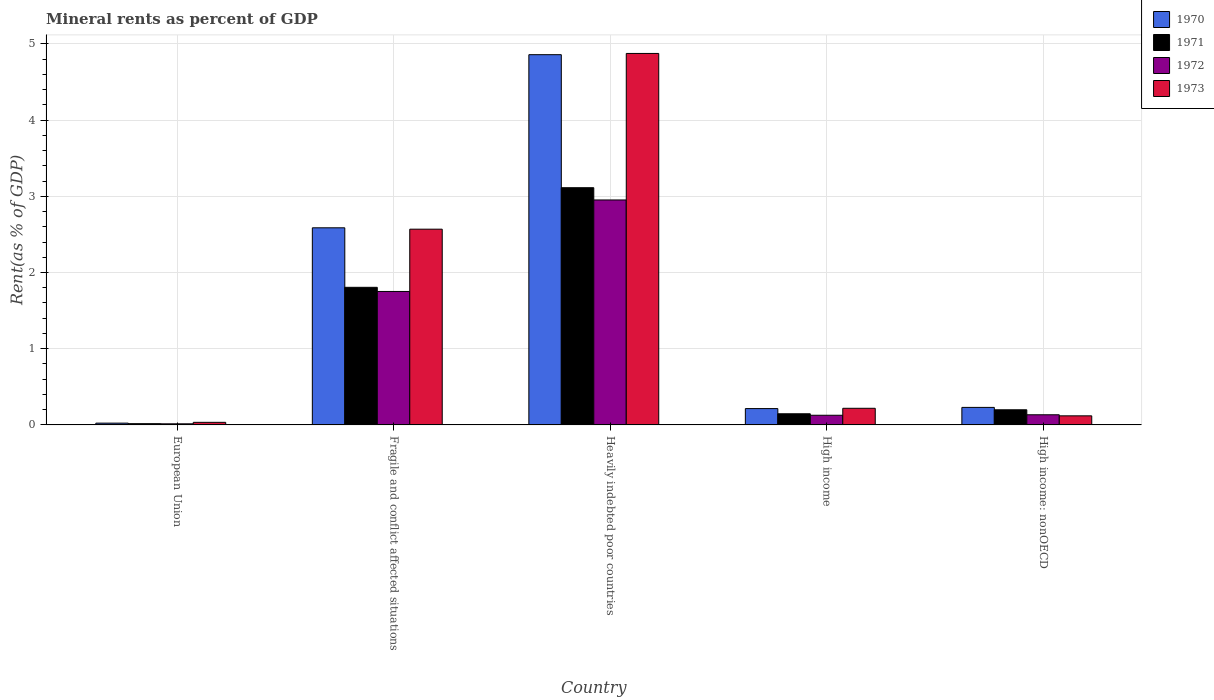How many different coloured bars are there?
Keep it short and to the point. 4. How many groups of bars are there?
Make the answer very short. 5. Are the number of bars on each tick of the X-axis equal?
Offer a very short reply. Yes. How many bars are there on the 2nd tick from the left?
Your response must be concise. 4. How many bars are there on the 1st tick from the right?
Provide a short and direct response. 4. What is the label of the 1st group of bars from the left?
Provide a short and direct response. European Union. What is the mineral rent in 1973 in Fragile and conflict affected situations?
Ensure brevity in your answer.  2.57. Across all countries, what is the maximum mineral rent in 1972?
Ensure brevity in your answer.  2.95. Across all countries, what is the minimum mineral rent in 1973?
Your response must be concise. 0.03. In which country was the mineral rent in 1970 maximum?
Give a very brief answer. Heavily indebted poor countries. In which country was the mineral rent in 1973 minimum?
Your answer should be very brief. European Union. What is the total mineral rent in 1973 in the graph?
Your answer should be compact. 7.81. What is the difference between the mineral rent in 1972 in Fragile and conflict affected situations and that in High income?
Your response must be concise. 1.62. What is the difference between the mineral rent in 1972 in Fragile and conflict affected situations and the mineral rent in 1970 in European Union?
Provide a short and direct response. 1.73. What is the average mineral rent in 1970 per country?
Give a very brief answer. 1.58. What is the difference between the mineral rent of/in 1970 and mineral rent of/in 1971 in Fragile and conflict affected situations?
Offer a terse response. 0.78. What is the ratio of the mineral rent in 1973 in Fragile and conflict affected situations to that in Heavily indebted poor countries?
Your response must be concise. 0.53. What is the difference between the highest and the second highest mineral rent in 1972?
Provide a succinct answer. -1.62. What is the difference between the highest and the lowest mineral rent in 1970?
Keep it short and to the point. 4.83. In how many countries, is the mineral rent in 1973 greater than the average mineral rent in 1973 taken over all countries?
Your answer should be very brief. 2. Is the sum of the mineral rent in 1970 in Fragile and conflict affected situations and High income: nonOECD greater than the maximum mineral rent in 1971 across all countries?
Your answer should be compact. No. What does the 1st bar from the left in European Union represents?
Make the answer very short. 1970. How many bars are there?
Your response must be concise. 20. Are all the bars in the graph horizontal?
Offer a terse response. No. What is the difference between two consecutive major ticks on the Y-axis?
Ensure brevity in your answer.  1. Are the values on the major ticks of Y-axis written in scientific E-notation?
Provide a short and direct response. No. Does the graph contain grids?
Provide a succinct answer. Yes. Where does the legend appear in the graph?
Offer a very short reply. Top right. How many legend labels are there?
Your response must be concise. 4. How are the legend labels stacked?
Keep it short and to the point. Vertical. What is the title of the graph?
Offer a very short reply. Mineral rents as percent of GDP. What is the label or title of the Y-axis?
Provide a succinct answer. Rent(as % of GDP). What is the Rent(as % of GDP) of 1970 in European Union?
Your response must be concise. 0.02. What is the Rent(as % of GDP) of 1971 in European Union?
Your response must be concise. 0.02. What is the Rent(as % of GDP) of 1972 in European Union?
Offer a terse response. 0.01. What is the Rent(as % of GDP) of 1973 in European Union?
Make the answer very short. 0.03. What is the Rent(as % of GDP) of 1970 in Fragile and conflict affected situations?
Offer a very short reply. 2.59. What is the Rent(as % of GDP) in 1971 in Fragile and conflict affected situations?
Your answer should be very brief. 1.81. What is the Rent(as % of GDP) in 1972 in Fragile and conflict affected situations?
Keep it short and to the point. 1.75. What is the Rent(as % of GDP) of 1973 in Fragile and conflict affected situations?
Give a very brief answer. 2.57. What is the Rent(as % of GDP) in 1970 in Heavily indebted poor countries?
Provide a short and direct response. 4.86. What is the Rent(as % of GDP) in 1971 in Heavily indebted poor countries?
Your answer should be very brief. 3.11. What is the Rent(as % of GDP) of 1972 in Heavily indebted poor countries?
Ensure brevity in your answer.  2.95. What is the Rent(as % of GDP) of 1973 in Heavily indebted poor countries?
Keep it short and to the point. 4.87. What is the Rent(as % of GDP) in 1970 in High income?
Your answer should be compact. 0.21. What is the Rent(as % of GDP) in 1971 in High income?
Give a very brief answer. 0.15. What is the Rent(as % of GDP) of 1972 in High income?
Your response must be concise. 0.13. What is the Rent(as % of GDP) of 1973 in High income?
Ensure brevity in your answer.  0.22. What is the Rent(as % of GDP) in 1970 in High income: nonOECD?
Your answer should be compact. 0.23. What is the Rent(as % of GDP) of 1971 in High income: nonOECD?
Ensure brevity in your answer.  0.2. What is the Rent(as % of GDP) in 1972 in High income: nonOECD?
Your answer should be compact. 0.13. What is the Rent(as % of GDP) in 1973 in High income: nonOECD?
Provide a short and direct response. 0.12. Across all countries, what is the maximum Rent(as % of GDP) of 1970?
Provide a short and direct response. 4.86. Across all countries, what is the maximum Rent(as % of GDP) in 1971?
Offer a terse response. 3.11. Across all countries, what is the maximum Rent(as % of GDP) in 1972?
Offer a very short reply. 2.95. Across all countries, what is the maximum Rent(as % of GDP) in 1973?
Make the answer very short. 4.87. Across all countries, what is the minimum Rent(as % of GDP) of 1970?
Make the answer very short. 0.02. Across all countries, what is the minimum Rent(as % of GDP) of 1971?
Your answer should be compact. 0.02. Across all countries, what is the minimum Rent(as % of GDP) of 1972?
Give a very brief answer. 0.01. Across all countries, what is the minimum Rent(as % of GDP) in 1973?
Provide a succinct answer. 0.03. What is the total Rent(as % of GDP) of 1970 in the graph?
Provide a short and direct response. 7.91. What is the total Rent(as % of GDP) in 1971 in the graph?
Offer a very short reply. 5.28. What is the total Rent(as % of GDP) of 1972 in the graph?
Give a very brief answer. 4.98. What is the total Rent(as % of GDP) of 1973 in the graph?
Your response must be concise. 7.81. What is the difference between the Rent(as % of GDP) in 1970 in European Union and that in Fragile and conflict affected situations?
Provide a short and direct response. -2.56. What is the difference between the Rent(as % of GDP) in 1971 in European Union and that in Fragile and conflict affected situations?
Offer a terse response. -1.79. What is the difference between the Rent(as % of GDP) of 1972 in European Union and that in Fragile and conflict affected situations?
Provide a short and direct response. -1.74. What is the difference between the Rent(as % of GDP) in 1973 in European Union and that in Fragile and conflict affected situations?
Make the answer very short. -2.53. What is the difference between the Rent(as % of GDP) of 1970 in European Union and that in Heavily indebted poor countries?
Offer a very short reply. -4.83. What is the difference between the Rent(as % of GDP) in 1971 in European Union and that in Heavily indebted poor countries?
Ensure brevity in your answer.  -3.1. What is the difference between the Rent(as % of GDP) in 1972 in European Union and that in Heavily indebted poor countries?
Your answer should be compact. -2.94. What is the difference between the Rent(as % of GDP) of 1973 in European Union and that in Heavily indebted poor countries?
Keep it short and to the point. -4.84. What is the difference between the Rent(as % of GDP) in 1970 in European Union and that in High income?
Your answer should be very brief. -0.19. What is the difference between the Rent(as % of GDP) of 1971 in European Union and that in High income?
Your answer should be very brief. -0.13. What is the difference between the Rent(as % of GDP) in 1972 in European Union and that in High income?
Provide a short and direct response. -0.11. What is the difference between the Rent(as % of GDP) in 1973 in European Union and that in High income?
Offer a very short reply. -0.18. What is the difference between the Rent(as % of GDP) in 1970 in European Union and that in High income: nonOECD?
Your response must be concise. -0.21. What is the difference between the Rent(as % of GDP) of 1971 in European Union and that in High income: nonOECD?
Ensure brevity in your answer.  -0.18. What is the difference between the Rent(as % of GDP) of 1972 in European Union and that in High income: nonOECD?
Your answer should be very brief. -0.12. What is the difference between the Rent(as % of GDP) of 1973 in European Union and that in High income: nonOECD?
Your response must be concise. -0.09. What is the difference between the Rent(as % of GDP) of 1970 in Fragile and conflict affected situations and that in Heavily indebted poor countries?
Make the answer very short. -2.27. What is the difference between the Rent(as % of GDP) in 1971 in Fragile and conflict affected situations and that in Heavily indebted poor countries?
Offer a terse response. -1.31. What is the difference between the Rent(as % of GDP) of 1972 in Fragile and conflict affected situations and that in Heavily indebted poor countries?
Offer a very short reply. -1.2. What is the difference between the Rent(as % of GDP) of 1973 in Fragile and conflict affected situations and that in Heavily indebted poor countries?
Ensure brevity in your answer.  -2.31. What is the difference between the Rent(as % of GDP) in 1970 in Fragile and conflict affected situations and that in High income?
Ensure brevity in your answer.  2.37. What is the difference between the Rent(as % of GDP) of 1971 in Fragile and conflict affected situations and that in High income?
Make the answer very short. 1.66. What is the difference between the Rent(as % of GDP) in 1972 in Fragile and conflict affected situations and that in High income?
Make the answer very short. 1.62. What is the difference between the Rent(as % of GDP) in 1973 in Fragile and conflict affected situations and that in High income?
Provide a succinct answer. 2.35. What is the difference between the Rent(as % of GDP) of 1970 in Fragile and conflict affected situations and that in High income: nonOECD?
Ensure brevity in your answer.  2.36. What is the difference between the Rent(as % of GDP) in 1971 in Fragile and conflict affected situations and that in High income: nonOECD?
Your answer should be compact. 1.61. What is the difference between the Rent(as % of GDP) in 1972 in Fragile and conflict affected situations and that in High income: nonOECD?
Make the answer very short. 1.62. What is the difference between the Rent(as % of GDP) of 1973 in Fragile and conflict affected situations and that in High income: nonOECD?
Keep it short and to the point. 2.45. What is the difference between the Rent(as % of GDP) in 1970 in Heavily indebted poor countries and that in High income?
Provide a succinct answer. 4.64. What is the difference between the Rent(as % of GDP) in 1971 in Heavily indebted poor countries and that in High income?
Keep it short and to the point. 2.97. What is the difference between the Rent(as % of GDP) of 1972 in Heavily indebted poor countries and that in High income?
Keep it short and to the point. 2.82. What is the difference between the Rent(as % of GDP) in 1973 in Heavily indebted poor countries and that in High income?
Provide a succinct answer. 4.66. What is the difference between the Rent(as % of GDP) of 1970 in Heavily indebted poor countries and that in High income: nonOECD?
Offer a very short reply. 4.63. What is the difference between the Rent(as % of GDP) in 1971 in Heavily indebted poor countries and that in High income: nonOECD?
Offer a terse response. 2.91. What is the difference between the Rent(as % of GDP) of 1972 in Heavily indebted poor countries and that in High income: nonOECD?
Provide a succinct answer. 2.82. What is the difference between the Rent(as % of GDP) of 1973 in Heavily indebted poor countries and that in High income: nonOECD?
Provide a short and direct response. 4.75. What is the difference between the Rent(as % of GDP) of 1970 in High income and that in High income: nonOECD?
Offer a terse response. -0.02. What is the difference between the Rent(as % of GDP) of 1971 in High income and that in High income: nonOECD?
Give a very brief answer. -0.05. What is the difference between the Rent(as % of GDP) in 1972 in High income and that in High income: nonOECD?
Your answer should be compact. -0.01. What is the difference between the Rent(as % of GDP) of 1973 in High income and that in High income: nonOECD?
Your answer should be very brief. 0.1. What is the difference between the Rent(as % of GDP) in 1970 in European Union and the Rent(as % of GDP) in 1971 in Fragile and conflict affected situations?
Your response must be concise. -1.78. What is the difference between the Rent(as % of GDP) in 1970 in European Union and the Rent(as % of GDP) in 1972 in Fragile and conflict affected situations?
Ensure brevity in your answer.  -1.73. What is the difference between the Rent(as % of GDP) in 1970 in European Union and the Rent(as % of GDP) in 1973 in Fragile and conflict affected situations?
Make the answer very short. -2.54. What is the difference between the Rent(as % of GDP) of 1971 in European Union and the Rent(as % of GDP) of 1972 in Fragile and conflict affected situations?
Give a very brief answer. -1.73. What is the difference between the Rent(as % of GDP) of 1971 in European Union and the Rent(as % of GDP) of 1973 in Fragile and conflict affected situations?
Offer a terse response. -2.55. What is the difference between the Rent(as % of GDP) of 1972 in European Union and the Rent(as % of GDP) of 1973 in Fragile and conflict affected situations?
Ensure brevity in your answer.  -2.55. What is the difference between the Rent(as % of GDP) of 1970 in European Union and the Rent(as % of GDP) of 1971 in Heavily indebted poor countries?
Ensure brevity in your answer.  -3.09. What is the difference between the Rent(as % of GDP) in 1970 in European Union and the Rent(as % of GDP) in 1972 in Heavily indebted poor countries?
Offer a very short reply. -2.93. What is the difference between the Rent(as % of GDP) of 1970 in European Union and the Rent(as % of GDP) of 1973 in Heavily indebted poor countries?
Keep it short and to the point. -4.85. What is the difference between the Rent(as % of GDP) of 1971 in European Union and the Rent(as % of GDP) of 1972 in Heavily indebted poor countries?
Make the answer very short. -2.94. What is the difference between the Rent(as % of GDP) of 1971 in European Union and the Rent(as % of GDP) of 1973 in Heavily indebted poor countries?
Keep it short and to the point. -4.86. What is the difference between the Rent(as % of GDP) in 1972 in European Union and the Rent(as % of GDP) in 1973 in Heavily indebted poor countries?
Offer a terse response. -4.86. What is the difference between the Rent(as % of GDP) of 1970 in European Union and the Rent(as % of GDP) of 1971 in High income?
Give a very brief answer. -0.12. What is the difference between the Rent(as % of GDP) in 1970 in European Union and the Rent(as % of GDP) in 1972 in High income?
Provide a short and direct response. -0.1. What is the difference between the Rent(as % of GDP) of 1970 in European Union and the Rent(as % of GDP) of 1973 in High income?
Your answer should be very brief. -0.19. What is the difference between the Rent(as % of GDP) in 1971 in European Union and the Rent(as % of GDP) in 1972 in High income?
Keep it short and to the point. -0.11. What is the difference between the Rent(as % of GDP) of 1971 in European Union and the Rent(as % of GDP) of 1973 in High income?
Ensure brevity in your answer.  -0.2. What is the difference between the Rent(as % of GDP) in 1972 in European Union and the Rent(as % of GDP) in 1973 in High income?
Offer a terse response. -0.2. What is the difference between the Rent(as % of GDP) of 1970 in European Union and the Rent(as % of GDP) of 1971 in High income: nonOECD?
Offer a terse response. -0.18. What is the difference between the Rent(as % of GDP) in 1970 in European Union and the Rent(as % of GDP) in 1972 in High income: nonOECD?
Provide a short and direct response. -0.11. What is the difference between the Rent(as % of GDP) of 1970 in European Union and the Rent(as % of GDP) of 1973 in High income: nonOECD?
Provide a succinct answer. -0.1. What is the difference between the Rent(as % of GDP) in 1971 in European Union and the Rent(as % of GDP) in 1972 in High income: nonOECD?
Keep it short and to the point. -0.12. What is the difference between the Rent(as % of GDP) of 1971 in European Union and the Rent(as % of GDP) of 1973 in High income: nonOECD?
Offer a terse response. -0.1. What is the difference between the Rent(as % of GDP) in 1972 in European Union and the Rent(as % of GDP) in 1973 in High income: nonOECD?
Offer a very short reply. -0.1. What is the difference between the Rent(as % of GDP) of 1970 in Fragile and conflict affected situations and the Rent(as % of GDP) of 1971 in Heavily indebted poor countries?
Your answer should be compact. -0.53. What is the difference between the Rent(as % of GDP) of 1970 in Fragile and conflict affected situations and the Rent(as % of GDP) of 1972 in Heavily indebted poor countries?
Provide a short and direct response. -0.37. What is the difference between the Rent(as % of GDP) in 1970 in Fragile and conflict affected situations and the Rent(as % of GDP) in 1973 in Heavily indebted poor countries?
Give a very brief answer. -2.29. What is the difference between the Rent(as % of GDP) in 1971 in Fragile and conflict affected situations and the Rent(as % of GDP) in 1972 in Heavily indebted poor countries?
Offer a very short reply. -1.15. What is the difference between the Rent(as % of GDP) of 1971 in Fragile and conflict affected situations and the Rent(as % of GDP) of 1973 in Heavily indebted poor countries?
Offer a very short reply. -3.07. What is the difference between the Rent(as % of GDP) of 1972 in Fragile and conflict affected situations and the Rent(as % of GDP) of 1973 in Heavily indebted poor countries?
Your answer should be very brief. -3.12. What is the difference between the Rent(as % of GDP) in 1970 in Fragile and conflict affected situations and the Rent(as % of GDP) in 1971 in High income?
Provide a succinct answer. 2.44. What is the difference between the Rent(as % of GDP) in 1970 in Fragile and conflict affected situations and the Rent(as % of GDP) in 1972 in High income?
Keep it short and to the point. 2.46. What is the difference between the Rent(as % of GDP) in 1970 in Fragile and conflict affected situations and the Rent(as % of GDP) in 1973 in High income?
Give a very brief answer. 2.37. What is the difference between the Rent(as % of GDP) of 1971 in Fragile and conflict affected situations and the Rent(as % of GDP) of 1972 in High income?
Provide a short and direct response. 1.68. What is the difference between the Rent(as % of GDP) in 1971 in Fragile and conflict affected situations and the Rent(as % of GDP) in 1973 in High income?
Keep it short and to the point. 1.59. What is the difference between the Rent(as % of GDP) of 1972 in Fragile and conflict affected situations and the Rent(as % of GDP) of 1973 in High income?
Offer a terse response. 1.53. What is the difference between the Rent(as % of GDP) in 1970 in Fragile and conflict affected situations and the Rent(as % of GDP) in 1971 in High income: nonOECD?
Provide a short and direct response. 2.39. What is the difference between the Rent(as % of GDP) of 1970 in Fragile and conflict affected situations and the Rent(as % of GDP) of 1972 in High income: nonOECD?
Offer a very short reply. 2.45. What is the difference between the Rent(as % of GDP) of 1970 in Fragile and conflict affected situations and the Rent(as % of GDP) of 1973 in High income: nonOECD?
Your answer should be compact. 2.47. What is the difference between the Rent(as % of GDP) of 1971 in Fragile and conflict affected situations and the Rent(as % of GDP) of 1972 in High income: nonOECD?
Your answer should be compact. 1.67. What is the difference between the Rent(as % of GDP) of 1971 in Fragile and conflict affected situations and the Rent(as % of GDP) of 1973 in High income: nonOECD?
Keep it short and to the point. 1.69. What is the difference between the Rent(as % of GDP) in 1972 in Fragile and conflict affected situations and the Rent(as % of GDP) in 1973 in High income: nonOECD?
Offer a terse response. 1.63. What is the difference between the Rent(as % of GDP) of 1970 in Heavily indebted poor countries and the Rent(as % of GDP) of 1971 in High income?
Provide a succinct answer. 4.71. What is the difference between the Rent(as % of GDP) of 1970 in Heavily indebted poor countries and the Rent(as % of GDP) of 1972 in High income?
Your answer should be compact. 4.73. What is the difference between the Rent(as % of GDP) in 1970 in Heavily indebted poor countries and the Rent(as % of GDP) in 1973 in High income?
Your answer should be very brief. 4.64. What is the difference between the Rent(as % of GDP) of 1971 in Heavily indebted poor countries and the Rent(as % of GDP) of 1972 in High income?
Keep it short and to the point. 2.99. What is the difference between the Rent(as % of GDP) of 1971 in Heavily indebted poor countries and the Rent(as % of GDP) of 1973 in High income?
Ensure brevity in your answer.  2.89. What is the difference between the Rent(as % of GDP) in 1972 in Heavily indebted poor countries and the Rent(as % of GDP) in 1973 in High income?
Make the answer very short. 2.73. What is the difference between the Rent(as % of GDP) of 1970 in Heavily indebted poor countries and the Rent(as % of GDP) of 1971 in High income: nonOECD?
Your answer should be very brief. 4.66. What is the difference between the Rent(as % of GDP) of 1970 in Heavily indebted poor countries and the Rent(as % of GDP) of 1972 in High income: nonOECD?
Your answer should be compact. 4.72. What is the difference between the Rent(as % of GDP) of 1970 in Heavily indebted poor countries and the Rent(as % of GDP) of 1973 in High income: nonOECD?
Offer a terse response. 4.74. What is the difference between the Rent(as % of GDP) in 1971 in Heavily indebted poor countries and the Rent(as % of GDP) in 1972 in High income: nonOECD?
Offer a very short reply. 2.98. What is the difference between the Rent(as % of GDP) in 1971 in Heavily indebted poor countries and the Rent(as % of GDP) in 1973 in High income: nonOECD?
Your answer should be compact. 2.99. What is the difference between the Rent(as % of GDP) in 1972 in Heavily indebted poor countries and the Rent(as % of GDP) in 1973 in High income: nonOECD?
Give a very brief answer. 2.83. What is the difference between the Rent(as % of GDP) of 1970 in High income and the Rent(as % of GDP) of 1971 in High income: nonOECD?
Keep it short and to the point. 0.02. What is the difference between the Rent(as % of GDP) of 1970 in High income and the Rent(as % of GDP) of 1972 in High income: nonOECD?
Ensure brevity in your answer.  0.08. What is the difference between the Rent(as % of GDP) in 1970 in High income and the Rent(as % of GDP) in 1973 in High income: nonOECD?
Keep it short and to the point. 0.1. What is the difference between the Rent(as % of GDP) in 1971 in High income and the Rent(as % of GDP) in 1972 in High income: nonOECD?
Give a very brief answer. 0.01. What is the difference between the Rent(as % of GDP) in 1971 in High income and the Rent(as % of GDP) in 1973 in High income: nonOECD?
Offer a terse response. 0.03. What is the difference between the Rent(as % of GDP) of 1972 in High income and the Rent(as % of GDP) of 1973 in High income: nonOECD?
Ensure brevity in your answer.  0.01. What is the average Rent(as % of GDP) in 1970 per country?
Offer a terse response. 1.58. What is the average Rent(as % of GDP) in 1971 per country?
Offer a terse response. 1.06. What is the average Rent(as % of GDP) in 1973 per country?
Provide a succinct answer. 1.56. What is the difference between the Rent(as % of GDP) in 1970 and Rent(as % of GDP) in 1971 in European Union?
Keep it short and to the point. 0.01. What is the difference between the Rent(as % of GDP) in 1970 and Rent(as % of GDP) in 1972 in European Union?
Give a very brief answer. 0.01. What is the difference between the Rent(as % of GDP) in 1970 and Rent(as % of GDP) in 1973 in European Union?
Offer a terse response. -0.01. What is the difference between the Rent(as % of GDP) in 1971 and Rent(as % of GDP) in 1972 in European Union?
Your answer should be compact. 0. What is the difference between the Rent(as % of GDP) in 1971 and Rent(as % of GDP) in 1973 in European Union?
Offer a very short reply. -0.02. What is the difference between the Rent(as % of GDP) in 1972 and Rent(as % of GDP) in 1973 in European Union?
Keep it short and to the point. -0.02. What is the difference between the Rent(as % of GDP) in 1970 and Rent(as % of GDP) in 1971 in Fragile and conflict affected situations?
Make the answer very short. 0.78. What is the difference between the Rent(as % of GDP) in 1970 and Rent(as % of GDP) in 1972 in Fragile and conflict affected situations?
Provide a short and direct response. 0.84. What is the difference between the Rent(as % of GDP) of 1970 and Rent(as % of GDP) of 1973 in Fragile and conflict affected situations?
Offer a terse response. 0.02. What is the difference between the Rent(as % of GDP) of 1971 and Rent(as % of GDP) of 1972 in Fragile and conflict affected situations?
Provide a succinct answer. 0.05. What is the difference between the Rent(as % of GDP) in 1971 and Rent(as % of GDP) in 1973 in Fragile and conflict affected situations?
Ensure brevity in your answer.  -0.76. What is the difference between the Rent(as % of GDP) in 1972 and Rent(as % of GDP) in 1973 in Fragile and conflict affected situations?
Your answer should be compact. -0.82. What is the difference between the Rent(as % of GDP) in 1970 and Rent(as % of GDP) in 1971 in Heavily indebted poor countries?
Your answer should be very brief. 1.75. What is the difference between the Rent(as % of GDP) of 1970 and Rent(as % of GDP) of 1972 in Heavily indebted poor countries?
Keep it short and to the point. 1.91. What is the difference between the Rent(as % of GDP) in 1970 and Rent(as % of GDP) in 1973 in Heavily indebted poor countries?
Ensure brevity in your answer.  -0.02. What is the difference between the Rent(as % of GDP) of 1971 and Rent(as % of GDP) of 1972 in Heavily indebted poor countries?
Provide a short and direct response. 0.16. What is the difference between the Rent(as % of GDP) in 1971 and Rent(as % of GDP) in 1973 in Heavily indebted poor countries?
Make the answer very short. -1.76. What is the difference between the Rent(as % of GDP) in 1972 and Rent(as % of GDP) in 1973 in Heavily indebted poor countries?
Your answer should be very brief. -1.92. What is the difference between the Rent(as % of GDP) in 1970 and Rent(as % of GDP) in 1971 in High income?
Offer a very short reply. 0.07. What is the difference between the Rent(as % of GDP) of 1970 and Rent(as % of GDP) of 1972 in High income?
Give a very brief answer. 0.09. What is the difference between the Rent(as % of GDP) in 1970 and Rent(as % of GDP) in 1973 in High income?
Ensure brevity in your answer.  -0. What is the difference between the Rent(as % of GDP) in 1971 and Rent(as % of GDP) in 1972 in High income?
Make the answer very short. 0.02. What is the difference between the Rent(as % of GDP) in 1971 and Rent(as % of GDP) in 1973 in High income?
Your response must be concise. -0.07. What is the difference between the Rent(as % of GDP) in 1972 and Rent(as % of GDP) in 1973 in High income?
Offer a very short reply. -0.09. What is the difference between the Rent(as % of GDP) of 1970 and Rent(as % of GDP) of 1971 in High income: nonOECD?
Your response must be concise. 0.03. What is the difference between the Rent(as % of GDP) in 1970 and Rent(as % of GDP) in 1972 in High income: nonOECD?
Provide a short and direct response. 0.1. What is the difference between the Rent(as % of GDP) in 1970 and Rent(as % of GDP) in 1973 in High income: nonOECD?
Your response must be concise. 0.11. What is the difference between the Rent(as % of GDP) of 1971 and Rent(as % of GDP) of 1972 in High income: nonOECD?
Your answer should be compact. 0.07. What is the difference between the Rent(as % of GDP) of 1971 and Rent(as % of GDP) of 1973 in High income: nonOECD?
Provide a succinct answer. 0.08. What is the difference between the Rent(as % of GDP) in 1972 and Rent(as % of GDP) in 1973 in High income: nonOECD?
Offer a very short reply. 0.01. What is the ratio of the Rent(as % of GDP) of 1970 in European Union to that in Fragile and conflict affected situations?
Offer a very short reply. 0.01. What is the ratio of the Rent(as % of GDP) in 1971 in European Union to that in Fragile and conflict affected situations?
Keep it short and to the point. 0.01. What is the ratio of the Rent(as % of GDP) in 1972 in European Union to that in Fragile and conflict affected situations?
Offer a terse response. 0.01. What is the ratio of the Rent(as % of GDP) of 1973 in European Union to that in Fragile and conflict affected situations?
Your answer should be very brief. 0.01. What is the ratio of the Rent(as % of GDP) of 1970 in European Union to that in Heavily indebted poor countries?
Keep it short and to the point. 0. What is the ratio of the Rent(as % of GDP) in 1971 in European Union to that in Heavily indebted poor countries?
Ensure brevity in your answer.  0.01. What is the ratio of the Rent(as % of GDP) of 1972 in European Union to that in Heavily indebted poor countries?
Make the answer very short. 0. What is the ratio of the Rent(as % of GDP) in 1973 in European Union to that in Heavily indebted poor countries?
Your response must be concise. 0.01. What is the ratio of the Rent(as % of GDP) of 1970 in European Union to that in High income?
Make the answer very short. 0.11. What is the ratio of the Rent(as % of GDP) in 1971 in European Union to that in High income?
Your response must be concise. 0.11. What is the ratio of the Rent(as % of GDP) of 1972 in European Union to that in High income?
Keep it short and to the point. 0.11. What is the ratio of the Rent(as % of GDP) of 1973 in European Union to that in High income?
Your response must be concise. 0.15. What is the ratio of the Rent(as % of GDP) of 1970 in European Union to that in High income: nonOECD?
Give a very brief answer. 0.1. What is the ratio of the Rent(as % of GDP) of 1971 in European Union to that in High income: nonOECD?
Ensure brevity in your answer.  0.08. What is the ratio of the Rent(as % of GDP) of 1972 in European Union to that in High income: nonOECD?
Offer a terse response. 0.11. What is the ratio of the Rent(as % of GDP) in 1973 in European Union to that in High income: nonOECD?
Keep it short and to the point. 0.28. What is the ratio of the Rent(as % of GDP) of 1970 in Fragile and conflict affected situations to that in Heavily indebted poor countries?
Your answer should be compact. 0.53. What is the ratio of the Rent(as % of GDP) of 1971 in Fragile and conflict affected situations to that in Heavily indebted poor countries?
Ensure brevity in your answer.  0.58. What is the ratio of the Rent(as % of GDP) of 1972 in Fragile and conflict affected situations to that in Heavily indebted poor countries?
Your response must be concise. 0.59. What is the ratio of the Rent(as % of GDP) of 1973 in Fragile and conflict affected situations to that in Heavily indebted poor countries?
Give a very brief answer. 0.53. What is the ratio of the Rent(as % of GDP) in 1970 in Fragile and conflict affected situations to that in High income?
Offer a terse response. 12.08. What is the ratio of the Rent(as % of GDP) of 1971 in Fragile and conflict affected situations to that in High income?
Offer a terse response. 12.36. What is the ratio of the Rent(as % of GDP) in 1972 in Fragile and conflict affected situations to that in High income?
Offer a terse response. 13.82. What is the ratio of the Rent(as % of GDP) of 1973 in Fragile and conflict affected situations to that in High income?
Keep it short and to the point. 11.78. What is the ratio of the Rent(as % of GDP) in 1970 in Fragile and conflict affected situations to that in High income: nonOECD?
Your answer should be compact. 11.26. What is the ratio of the Rent(as % of GDP) of 1971 in Fragile and conflict affected situations to that in High income: nonOECD?
Provide a short and direct response. 9.09. What is the ratio of the Rent(as % of GDP) in 1972 in Fragile and conflict affected situations to that in High income: nonOECD?
Make the answer very short. 13.15. What is the ratio of the Rent(as % of GDP) in 1973 in Fragile and conflict affected situations to that in High income: nonOECD?
Provide a succinct answer. 21.58. What is the ratio of the Rent(as % of GDP) in 1970 in Heavily indebted poor countries to that in High income?
Your answer should be very brief. 22.69. What is the ratio of the Rent(as % of GDP) of 1971 in Heavily indebted poor countries to that in High income?
Ensure brevity in your answer.  21.31. What is the ratio of the Rent(as % of GDP) of 1972 in Heavily indebted poor countries to that in High income?
Keep it short and to the point. 23.3. What is the ratio of the Rent(as % of GDP) of 1973 in Heavily indebted poor countries to that in High income?
Keep it short and to the point. 22.35. What is the ratio of the Rent(as % of GDP) of 1970 in Heavily indebted poor countries to that in High income: nonOECD?
Provide a short and direct response. 21.14. What is the ratio of the Rent(as % of GDP) of 1971 in Heavily indebted poor countries to that in High income: nonOECD?
Keep it short and to the point. 15.68. What is the ratio of the Rent(as % of GDP) of 1972 in Heavily indebted poor countries to that in High income: nonOECD?
Provide a succinct answer. 22.17. What is the ratio of the Rent(as % of GDP) in 1973 in Heavily indebted poor countries to that in High income: nonOECD?
Offer a terse response. 40.95. What is the ratio of the Rent(as % of GDP) in 1970 in High income to that in High income: nonOECD?
Your answer should be compact. 0.93. What is the ratio of the Rent(as % of GDP) in 1971 in High income to that in High income: nonOECD?
Provide a succinct answer. 0.74. What is the ratio of the Rent(as % of GDP) of 1972 in High income to that in High income: nonOECD?
Your answer should be compact. 0.95. What is the ratio of the Rent(as % of GDP) of 1973 in High income to that in High income: nonOECD?
Provide a succinct answer. 1.83. What is the difference between the highest and the second highest Rent(as % of GDP) of 1970?
Offer a terse response. 2.27. What is the difference between the highest and the second highest Rent(as % of GDP) in 1971?
Provide a succinct answer. 1.31. What is the difference between the highest and the second highest Rent(as % of GDP) of 1972?
Your answer should be very brief. 1.2. What is the difference between the highest and the second highest Rent(as % of GDP) of 1973?
Provide a short and direct response. 2.31. What is the difference between the highest and the lowest Rent(as % of GDP) of 1970?
Keep it short and to the point. 4.83. What is the difference between the highest and the lowest Rent(as % of GDP) of 1971?
Your answer should be compact. 3.1. What is the difference between the highest and the lowest Rent(as % of GDP) in 1972?
Keep it short and to the point. 2.94. What is the difference between the highest and the lowest Rent(as % of GDP) of 1973?
Offer a terse response. 4.84. 